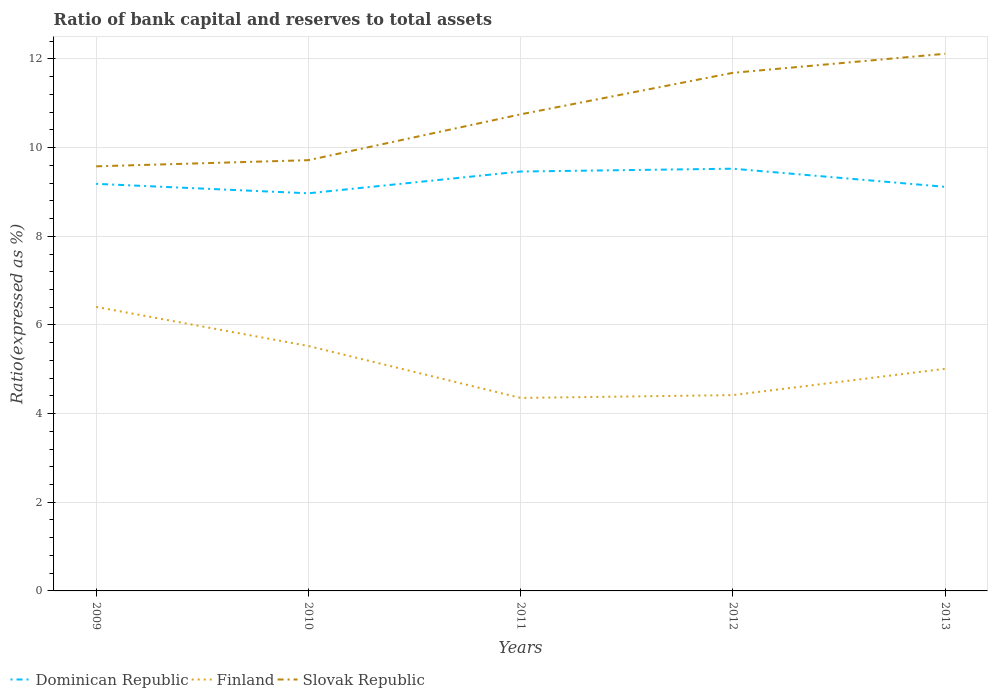How many different coloured lines are there?
Offer a very short reply. 3. Is the number of lines equal to the number of legend labels?
Your answer should be very brief. Yes. Across all years, what is the maximum ratio of bank capital and reserves to total assets in Slovak Republic?
Provide a short and direct response. 9.58. What is the total ratio of bank capital and reserves to total assets in Finland in the graph?
Provide a succinct answer. 1.11. What is the difference between the highest and the second highest ratio of bank capital and reserves to total assets in Finland?
Provide a short and direct response. 2.05. What is the difference between the highest and the lowest ratio of bank capital and reserves to total assets in Finland?
Give a very brief answer. 2. Is the ratio of bank capital and reserves to total assets in Slovak Republic strictly greater than the ratio of bank capital and reserves to total assets in Dominican Republic over the years?
Your response must be concise. No. What is the difference between two consecutive major ticks on the Y-axis?
Offer a terse response. 2. Are the values on the major ticks of Y-axis written in scientific E-notation?
Offer a terse response. No. Does the graph contain any zero values?
Make the answer very short. No. Where does the legend appear in the graph?
Your answer should be compact. Bottom left. How many legend labels are there?
Your response must be concise. 3. How are the legend labels stacked?
Provide a succinct answer. Horizontal. What is the title of the graph?
Your response must be concise. Ratio of bank capital and reserves to total assets. What is the label or title of the X-axis?
Your answer should be compact. Years. What is the label or title of the Y-axis?
Make the answer very short. Ratio(expressed as %). What is the Ratio(expressed as %) of Dominican Republic in 2009?
Make the answer very short. 9.18. What is the Ratio(expressed as %) in Finland in 2009?
Provide a succinct answer. 6.41. What is the Ratio(expressed as %) in Slovak Republic in 2009?
Provide a short and direct response. 9.58. What is the Ratio(expressed as %) in Dominican Republic in 2010?
Your answer should be compact. 8.97. What is the Ratio(expressed as %) of Finland in 2010?
Keep it short and to the point. 5.52. What is the Ratio(expressed as %) in Slovak Republic in 2010?
Provide a short and direct response. 9.72. What is the Ratio(expressed as %) of Dominican Republic in 2011?
Make the answer very short. 9.46. What is the Ratio(expressed as %) of Finland in 2011?
Provide a succinct answer. 4.35. What is the Ratio(expressed as %) of Slovak Republic in 2011?
Your answer should be very brief. 10.75. What is the Ratio(expressed as %) in Dominican Republic in 2012?
Offer a terse response. 9.52. What is the Ratio(expressed as %) in Finland in 2012?
Ensure brevity in your answer.  4.42. What is the Ratio(expressed as %) in Slovak Republic in 2012?
Your answer should be very brief. 11.69. What is the Ratio(expressed as %) of Dominican Republic in 2013?
Make the answer very short. 9.12. What is the Ratio(expressed as %) in Finland in 2013?
Keep it short and to the point. 5.01. What is the Ratio(expressed as %) in Slovak Republic in 2013?
Offer a very short reply. 12.12. Across all years, what is the maximum Ratio(expressed as %) of Dominican Republic?
Provide a succinct answer. 9.52. Across all years, what is the maximum Ratio(expressed as %) of Finland?
Provide a short and direct response. 6.41. Across all years, what is the maximum Ratio(expressed as %) of Slovak Republic?
Provide a succinct answer. 12.12. Across all years, what is the minimum Ratio(expressed as %) of Dominican Republic?
Provide a succinct answer. 8.97. Across all years, what is the minimum Ratio(expressed as %) in Finland?
Keep it short and to the point. 4.35. Across all years, what is the minimum Ratio(expressed as %) of Slovak Republic?
Keep it short and to the point. 9.58. What is the total Ratio(expressed as %) in Dominican Republic in the graph?
Your answer should be compact. 46.25. What is the total Ratio(expressed as %) of Finland in the graph?
Offer a terse response. 25.71. What is the total Ratio(expressed as %) of Slovak Republic in the graph?
Ensure brevity in your answer.  53.85. What is the difference between the Ratio(expressed as %) of Dominican Republic in 2009 and that in 2010?
Your response must be concise. 0.21. What is the difference between the Ratio(expressed as %) of Finland in 2009 and that in 2010?
Your answer should be very brief. 0.88. What is the difference between the Ratio(expressed as %) in Slovak Republic in 2009 and that in 2010?
Your answer should be very brief. -0.14. What is the difference between the Ratio(expressed as %) in Dominican Republic in 2009 and that in 2011?
Ensure brevity in your answer.  -0.28. What is the difference between the Ratio(expressed as %) of Finland in 2009 and that in 2011?
Ensure brevity in your answer.  2.05. What is the difference between the Ratio(expressed as %) in Slovak Republic in 2009 and that in 2011?
Your answer should be compact. -1.17. What is the difference between the Ratio(expressed as %) of Dominican Republic in 2009 and that in 2012?
Provide a succinct answer. -0.34. What is the difference between the Ratio(expressed as %) of Finland in 2009 and that in 2012?
Your answer should be compact. 1.99. What is the difference between the Ratio(expressed as %) of Slovak Republic in 2009 and that in 2012?
Provide a succinct answer. -2.11. What is the difference between the Ratio(expressed as %) of Dominican Republic in 2009 and that in 2013?
Provide a short and direct response. 0.07. What is the difference between the Ratio(expressed as %) of Finland in 2009 and that in 2013?
Keep it short and to the point. 1.4. What is the difference between the Ratio(expressed as %) of Slovak Republic in 2009 and that in 2013?
Your answer should be very brief. -2.54. What is the difference between the Ratio(expressed as %) in Dominican Republic in 2010 and that in 2011?
Provide a short and direct response. -0.49. What is the difference between the Ratio(expressed as %) of Finland in 2010 and that in 2011?
Make the answer very short. 1.17. What is the difference between the Ratio(expressed as %) in Slovak Republic in 2010 and that in 2011?
Provide a succinct answer. -1.03. What is the difference between the Ratio(expressed as %) in Dominican Republic in 2010 and that in 2012?
Ensure brevity in your answer.  -0.56. What is the difference between the Ratio(expressed as %) of Finland in 2010 and that in 2012?
Keep it short and to the point. 1.11. What is the difference between the Ratio(expressed as %) of Slovak Republic in 2010 and that in 2012?
Your answer should be very brief. -1.97. What is the difference between the Ratio(expressed as %) in Dominican Republic in 2010 and that in 2013?
Ensure brevity in your answer.  -0.15. What is the difference between the Ratio(expressed as %) in Finland in 2010 and that in 2013?
Make the answer very short. 0.51. What is the difference between the Ratio(expressed as %) of Dominican Republic in 2011 and that in 2012?
Offer a very short reply. -0.06. What is the difference between the Ratio(expressed as %) of Finland in 2011 and that in 2012?
Keep it short and to the point. -0.06. What is the difference between the Ratio(expressed as %) of Slovak Republic in 2011 and that in 2012?
Give a very brief answer. -0.94. What is the difference between the Ratio(expressed as %) of Dominican Republic in 2011 and that in 2013?
Provide a short and direct response. 0.34. What is the difference between the Ratio(expressed as %) of Finland in 2011 and that in 2013?
Offer a very short reply. -0.66. What is the difference between the Ratio(expressed as %) of Slovak Republic in 2011 and that in 2013?
Ensure brevity in your answer.  -1.37. What is the difference between the Ratio(expressed as %) of Dominican Republic in 2012 and that in 2013?
Give a very brief answer. 0.41. What is the difference between the Ratio(expressed as %) in Finland in 2012 and that in 2013?
Your response must be concise. -0.59. What is the difference between the Ratio(expressed as %) of Slovak Republic in 2012 and that in 2013?
Keep it short and to the point. -0.43. What is the difference between the Ratio(expressed as %) of Dominican Republic in 2009 and the Ratio(expressed as %) of Finland in 2010?
Offer a terse response. 3.66. What is the difference between the Ratio(expressed as %) of Dominican Republic in 2009 and the Ratio(expressed as %) of Slovak Republic in 2010?
Your answer should be compact. -0.53. What is the difference between the Ratio(expressed as %) of Finland in 2009 and the Ratio(expressed as %) of Slovak Republic in 2010?
Offer a very short reply. -3.31. What is the difference between the Ratio(expressed as %) of Dominican Republic in 2009 and the Ratio(expressed as %) of Finland in 2011?
Your response must be concise. 4.83. What is the difference between the Ratio(expressed as %) in Dominican Republic in 2009 and the Ratio(expressed as %) in Slovak Republic in 2011?
Your answer should be compact. -1.57. What is the difference between the Ratio(expressed as %) in Finland in 2009 and the Ratio(expressed as %) in Slovak Republic in 2011?
Offer a very short reply. -4.34. What is the difference between the Ratio(expressed as %) in Dominican Republic in 2009 and the Ratio(expressed as %) in Finland in 2012?
Make the answer very short. 4.77. What is the difference between the Ratio(expressed as %) of Dominican Republic in 2009 and the Ratio(expressed as %) of Slovak Republic in 2012?
Offer a terse response. -2.5. What is the difference between the Ratio(expressed as %) of Finland in 2009 and the Ratio(expressed as %) of Slovak Republic in 2012?
Make the answer very short. -5.28. What is the difference between the Ratio(expressed as %) of Dominican Republic in 2009 and the Ratio(expressed as %) of Finland in 2013?
Your response must be concise. 4.17. What is the difference between the Ratio(expressed as %) in Dominican Republic in 2009 and the Ratio(expressed as %) in Slovak Republic in 2013?
Make the answer very short. -2.93. What is the difference between the Ratio(expressed as %) in Finland in 2009 and the Ratio(expressed as %) in Slovak Republic in 2013?
Provide a succinct answer. -5.71. What is the difference between the Ratio(expressed as %) in Dominican Republic in 2010 and the Ratio(expressed as %) in Finland in 2011?
Give a very brief answer. 4.62. What is the difference between the Ratio(expressed as %) of Dominican Republic in 2010 and the Ratio(expressed as %) of Slovak Republic in 2011?
Your answer should be very brief. -1.78. What is the difference between the Ratio(expressed as %) in Finland in 2010 and the Ratio(expressed as %) in Slovak Republic in 2011?
Your response must be concise. -5.23. What is the difference between the Ratio(expressed as %) of Dominican Republic in 2010 and the Ratio(expressed as %) of Finland in 2012?
Your response must be concise. 4.55. What is the difference between the Ratio(expressed as %) of Dominican Republic in 2010 and the Ratio(expressed as %) of Slovak Republic in 2012?
Provide a succinct answer. -2.72. What is the difference between the Ratio(expressed as %) of Finland in 2010 and the Ratio(expressed as %) of Slovak Republic in 2012?
Your answer should be very brief. -6.16. What is the difference between the Ratio(expressed as %) in Dominican Republic in 2010 and the Ratio(expressed as %) in Finland in 2013?
Ensure brevity in your answer.  3.96. What is the difference between the Ratio(expressed as %) in Dominican Republic in 2010 and the Ratio(expressed as %) in Slovak Republic in 2013?
Offer a terse response. -3.15. What is the difference between the Ratio(expressed as %) of Finland in 2010 and the Ratio(expressed as %) of Slovak Republic in 2013?
Give a very brief answer. -6.59. What is the difference between the Ratio(expressed as %) of Dominican Republic in 2011 and the Ratio(expressed as %) of Finland in 2012?
Offer a terse response. 5.04. What is the difference between the Ratio(expressed as %) of Dominican Republic in 2011 and the Ratio(expressed as %) of Slovak Republic in 2012?
Ensure brevity in your answer.  -2.23. What is the difference between the Ratio(expressed as %) in Finland in 2011 and the Ratio(expressed as %) in Slovak Republic in 2012?
Give a very brief answer. -7.33. What is the difference between the Ratio(expressed as %) in Dominican Republic in 2011 and the Ratio(expressed as %) in Finland in 2013?
Your answer should be compact. 4.45. What is the difference between the Ratio(expressed as %) in Dominican Republic in 2011 and the Ratio(expressed as %) in Slovak Republic in 2013?
Offer a very short reply. -2.66. What is the difference between the Ratio(expressed as %) of Finland in 2011 and the Ratio(expressed as %) of Slovak Republic in 2013?
Offer a terse response. -7.76. What is the difference between the Ratio(expressed as %) in Dominican Republic in 2012 and the Ratio(expressed as %) in Finland in 2013?
Provide a succinct answer. 4.51. What is the difference between the Ratio(expressed as %) in Dominican Republic in 2012 and the Ratio(expressed as %) in Slovak Republic in 2013?
Provide a short and direct response. -2.59. What is the difference between the Ratio(expressed as %) in Finland in 2012 and the Ratio(expressed as %) in Slovak Republic in 2013?
Your answer should be compact. -7.7. What is the average Ratio(expressed as %) of Dominican Republic per year?
Ensure brevity in your answer.  9.25. What is the average Ratio(expressed as %) in Finland per year?
Provide a short and direct response. 5.14. What is the average Ratio(expressed as %) in Slovak Republic per year?
Give a very brief answer. 10.77. In the year 2009, what is the difference between the Ratio(expressed as %) of Dominican Republic and Ratio(expressed as %) of Finland?
Offer a terse response. 2.78. In the year 2009, what is the difference between the Ratio(expressed as %) of Dominican Republic and Ratio(expressed as %) of Slovak Republic?
Your response must be concise. -0.4. In the year 2009, what is the difference between the Ratio(expressed as %) in Finland and Ratio(expressed as %) in Slovak Republic?
Your answer should be very brief. -3.17. In the year 2010, what is the difference between the Ratio(expressed as %) in Dominican Republic and Ratio(expressed as %) in Finland?
Offer a very short reply. 3.44. In the year 2010, what is the difference between the Ratio(expressed as %) of Dominican Republic and Ratio(expressed as %) of Slovak Republic?
Your response must be concise. -0.75. In the year 2010, what is the difference between the Ratio(expressed as %) of Finland and Ratio(expressed as %) of Slovak Republic?
Provide a short and direct response. -4.19. In the year 2011, what is the difference between the Ratio(expressed as %) in Dominican Republic and Ratio(expressed as %) in Finland?
Provide a short and direct response. 5.11. In the year 2011, what is the difference between the Ratio(expressed as %) of Dominican Republic and Ratio(expressed as %) of Slovak Republic?
Provide a succinct answer. -1.29. In the year 2011, what is the difference between the Ratio(expressed as %) in Finland and Ratio(expressed as %) in Slovak Republic?
Provide a short and direct response. -6.4. In the year 2012, what is the difference between the Ratio(expressed as %) in Dominican Republic and Ratio(expressed as %) in Finland?
Ensure brevity in your answer.  5.11. In the year 2012, what is the difference between the Ratio(expressed as %) of Dominican Republic and Ratio(expressed as %) of Slovak Republic?
Your response must be concise. -2.16. In the year 2012, what is the difference between the Ratio(expressed as %) in Finland and Ratio(expressed as %) in Slovak Republic?
Ensure brevity in your answer.  -7.27. In the year 2013, what is the difference between the Ratio(expressed as %) of Dominican Republic and Ratio(expressed as %) of Finland?
Offer a terse response. 4.1. In the year 2013, what is the difference between the Ratio(expressed as %) in Dominican Republic and Ratio(expressed as %) in Slovak Republic?
Your answer should be compact. -3. In the year 2013, what is the difference between the Ratio(expressed as %) in Finland and Ratio(expressed as %) in Slovak Republic?
Your answer should be very brief. -7.11. What is the ratio of the Ratio(expressed as %) of Dominican Republic in 2009 to that in 2010?
Keep it short and to the point. 1.02. What is the ratio of the Ratio(expressed as %) of Finland in 2009 to that in 2010?
Give a very brief answer. 1.16. What is the ratio of the Ratio(expressed as %) in Slovak Republic in 2009 to that in 2010?
Your answer should be very brief. 0.99. What is the ratio of the Ratio(expressed as %) in Dominican Republic in 2009 to that in 2011?
Keep it short and to the point. 0.97. What is the ratio of the Ratio(expressed as %) in Finland in 2009 to that in 2011?
Your answer should be compact. 1.47. What is the ratio of the Ratio(expressed as %) in Slovak Republic in 2009 to that in 2011?
Offer a very short reply. 0.89. What is the ratio of the Ratio(expressed as %) of Dominican Republic in 2009 to that in 2012?
Provide a short and direct response. 0.96. What is the ratio of the Ratio(expressed as %) of Finland in 2009 to that in 2012?
Your response must be concise. 1.45. What is the ratio of the Ratio(expressed as %) in Slovak Republic in 2009 to that in 2012?
Your response must be concise. 0.82. What is the ratio of the Ratio(expressed as %) of Dominican Republic in 2009 to that in 2013?
Your response must be concise. 1.01. What is the ratio of the Ratio(expressed as %) of Finland in 2009 to that in 2013?
Your answer should be very brief. 1.28. What is the ratio of the Ratio(expressed as %) of Slovak Republic in 2009 to that in 2013?
Offer a terse response. 0.79. What is the ratio of the Ratio(expressed as %) of Dominican Republic in 2010 to that in 2011?
Give a very brief answer. 0.95. What is the ratio of the Ratio(expressed as %) in Finland in 2010 to that in 2011?
Offer a terse response. 1.27. What is the ratio of the Ratio(expressed as %) in Slovak Republic in 2010 to that in 2011?
Provide a short and direct response. 0.9. What is the ratio of the Ratio(expressed as %) in Dominican Republic in 2010 to that in 2012?
Keep it short and to the point. 0.94. What is the ratio of the Ratio(expressed as %) in Finland in 2010 to that in 2012?
Make the answer very short. 1.25. What is the ratio of the Ratio(expressed as %) of Slovak Republic in 2010 to that in 2012?
Provide a short and direct response. 0.83. What is the ratio of the Ratio(expressed as %) in Finland in 2010 to that in 2013?
Offer a terse response. 1.1. What is the ratio of the Ratio(expressed as %) of Slovak Republic in 2010 to that in 2013?
Give a very brief answer. 0.8. What is the ratio of the Ratio(expressed as %) of Dominican Republic in 2011 to that in 2012?
Provide a short and direct response. 0.99. What is the ratio of the Ratio(expressed as %) in Finland in 2011 to that in 2012?
Ensure brevity in your answer.  0.99. What is the ratio of the Ratio(expressed as %) in Slovak Republic in 2011 to that in 2012?
Ensure brevity in your answer.  0.92. What is the ratio of the Ratio(expressed as %) of Dominican Republic in 2011 to that in 2013?
Keep it short and to the point. 1.04. What is the ratio of the Ratio(expressed as %) in Finland in 2011 to that in 2013?
Offer a terse response. 0.87. What is the ratio of the Ratio(expressed as %) in Slovak Republic in 2011 to that in 2013?
Offer a terse response. 0.89. What is the ratio of the Ratio(expressed as %) of Dominican Republic in 2012 to that in 2013?
Ensure brevity in your answer.  1.04. What is the ratio of the Ratio(expressed as %) in Finland in 2012 to that in 2013?
Keep it short and to the point. 0.88. What is the ratio of the Ratio(expressed as %) of Slovak Republic in 2012 to that in 2013?
Offer a very short reply. 0.96. What is the difference between the highest and the second highest Ratio(expressed as %) of Dominican Republic?
Provide a succinct answer. 0.06. What is the difference between the highest and the second highest Ratio(expressed as %) of Finland?
Offer a terse response. 0.88. What is the difference between the highest and the second highest Ratio(expressed as %) of Slovak Republic?
Your response must be concise. 0.43. What is the difference between the highest and the lowest Ratio(expressed as %) of Dominican Republic?
Offer a very short reply. 0.56. What is the difference between the highest and the lowest Ratio(expressed as %) of Finland?
Your answer should be very brief. 2.05. What is the difference between the highest and the lowest Ratio(expressed as %) of Slovak Republic?
Provide a succinct answer. 2.54. 